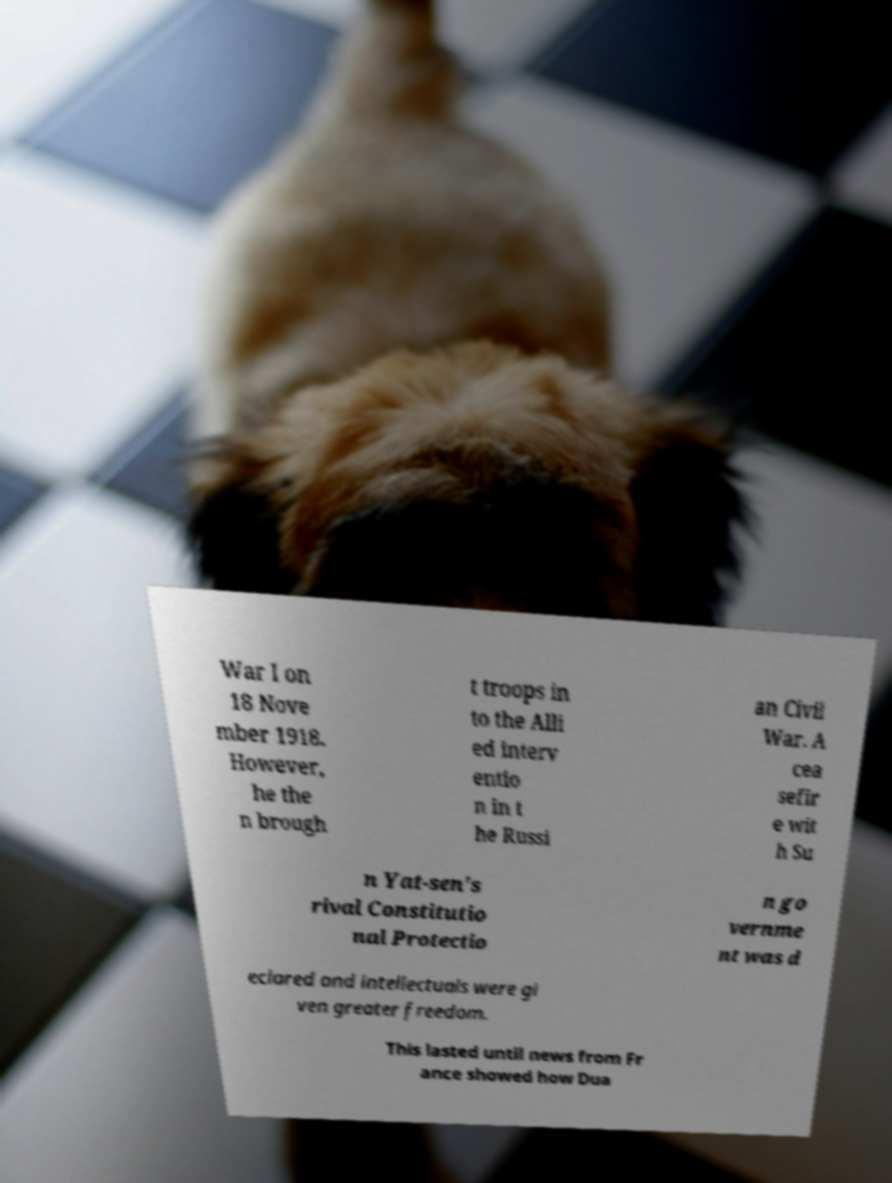Can you accurately transcribe the text from the provided image for me? War I on 18 Nove mber 1918. However, he the n brough t troops in to the Alli ed interv entio n in t he Russi an Civil War. A cea sefir e wit h Su n Yat-sen's rival Constitutio nal Protectio n go vernme nt was d eclared and intellectuals were gi ven greater freedom. This lasted until news from Fr ance showed how Dua 